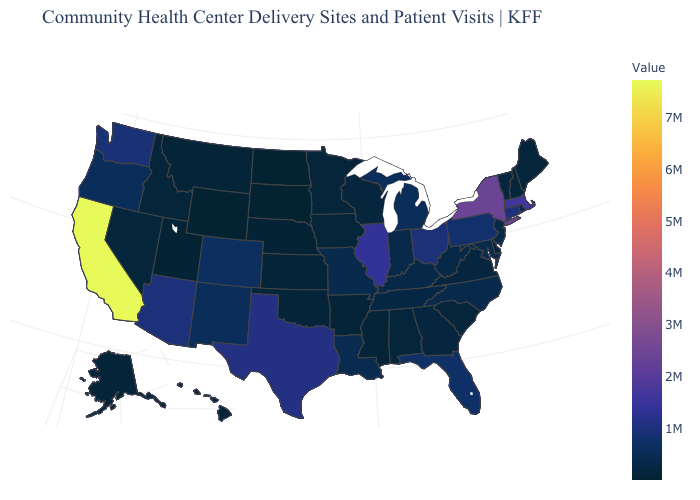Does Colorado have the lowest value in the West?
Quick response, please. No. Among the states that border Oregon , which have the lowest value?
Quick response, please. Idaho. Does Delaware have the lowest value in the South?
Quick response, please. Yes. Does California have the highest value in the West?
Keep it brief. Yes. Which states have the lowest value in the West?
Be succinct. Wyoming. Does Illinois have the highest value in the MidWest?
Be succinct. Yes. Is the legend a continuous bar?
Quick response, please. Yes. 